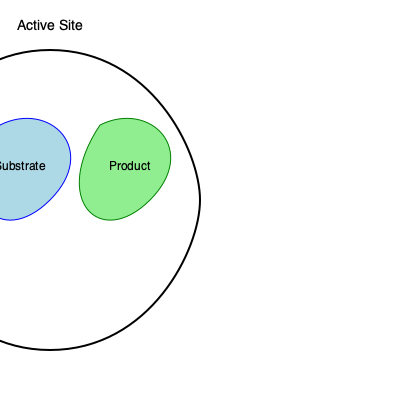Based on the 3D structure of the enzyme shown, which of the following statements about the catalytic mechanism is most likely true?

A) The enzyme follows a lock-and-key model
B) The enzyme undergoes induced fit
C) The enzyme has multiple active sites
D) The enzyme is non-specific in its binding To answer this question, we need to analyze the 3D structure of the enzyme shown in the diagram:

1. The enzyme is depicted with a large, flexible central region that forms a pocket or cleft.

2. Two distinct regions are shown within this pocket: one labeled "Substrate" (in blue) and another labeled "Product" (in green).

3. The overall shape of the enzyme is not rigid, but appears to have a degree of flexibility, as indicated by the curved lines forming its structure.

4. The active site is labeled at the top of the enzyme, encompassing the region where the substrate and product are located.

Given these observations:

A) The lock-and-key model suggests a rigid, preformed active site that perfectly matches the substrate. This doesn't align with the flexible structure shown.

B) The induced fit model proposes that the enzyme's active site changes shape to accommodate the substrate. This is consistent with the flexible structure and the presence of distinct substrate and product regions, suggesting a conformational change during catalysis.

C) While the diagram shows one active site, there's no evidence of multiple active sites.

D) The presence of a specific labeled substrate region argues against non-specific binding.

Therefore, the most likely true statement is that the enzyme undergoes induced fit.
Answer: B) The enzyme undergoes induced fit 